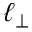Convert formula to latex. <formula><loc_0><loc_0><loc_500><loc_500>\ell _ { \perp }</formula> 